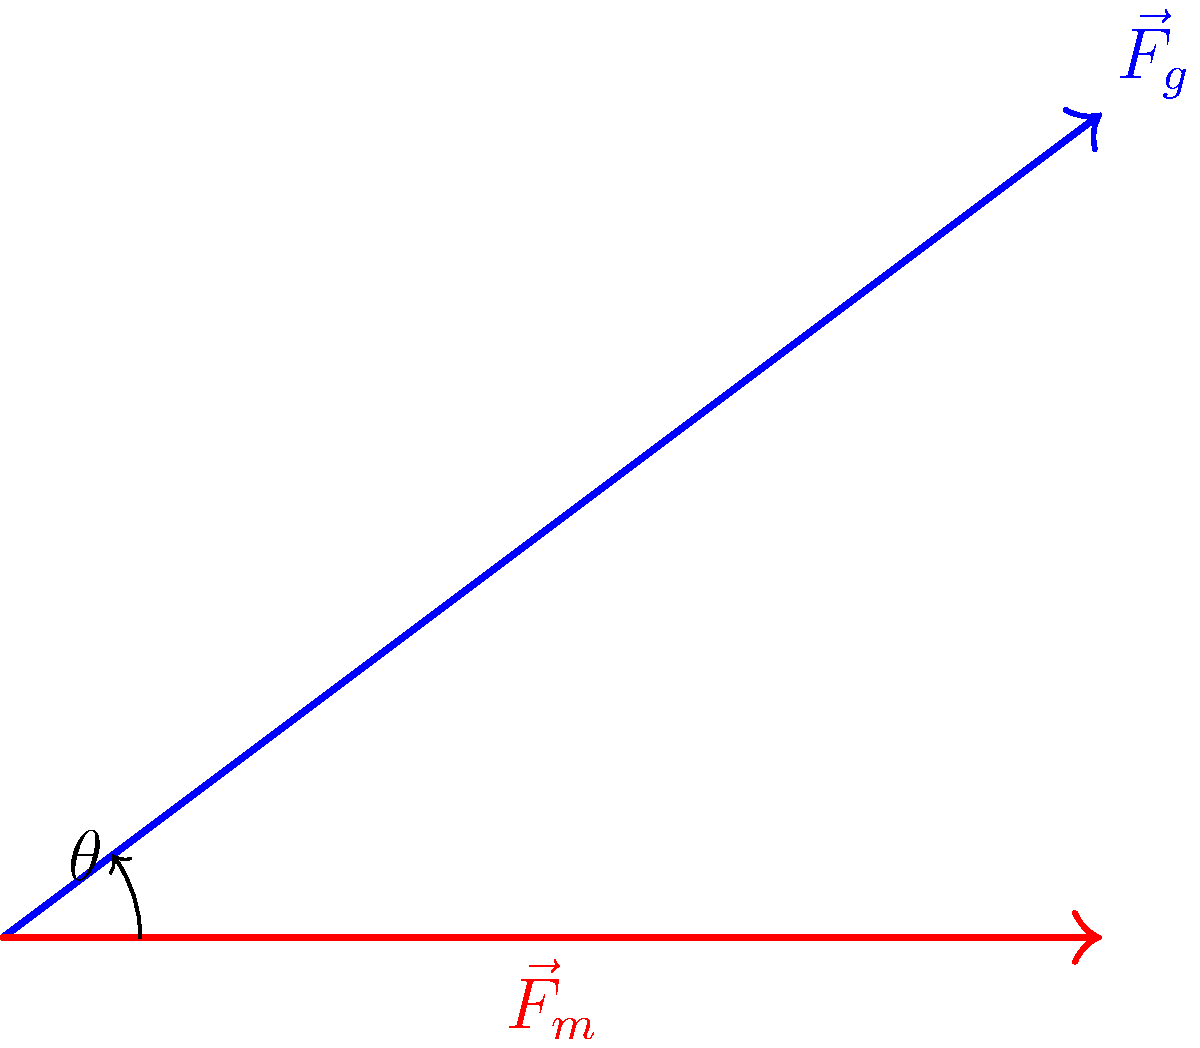In a barbell squat, the total force vector ($\vec{F}_t$) is composed of the gravitational force ($\vec{F}_g$) and the muscle force ($\vec{F}_m$). If $\vec{F}_g = 4\hat{i} + 3\hat{j}$ and $\vec{F}_m = 4\hat{i}$, calculate the magnitude of the total force vector $\vec{F}_t$. To solve this problem, we'll follow these steps:

1) First, we need to add the two force vectors to get the total force vector:
   $\vec{F}_t = \vec{F}_g + \vec{F}_m$

2) We're given:
   $\vec{F}_g = 4\hat{i} + 3\hat{j}$
   $\vec{F}_m = 4\hat{i}$

3) Adding these vectors:
   $\vec{F}_t = (4\hat{i} + 3\hat{j}) + (4\hat{i})$
   $\vec{F}_t = 8\hat{i} + 3\hat{j}$

4) To find the magnitude of $\vec{F}_t$, we use the Pythagorean theorem:
   $|\vec{F}_t| = \sqrt{(8)^2 + (3)^2}$

5) Simplify:
   $|\vec{F}_t| = \sqrt{64 + 9} = \sqrt{73}$

Therefore, the magnitude of the total force vector is $\sqrt{73}$ units.
Answer: $\sqrt{73}$ units 